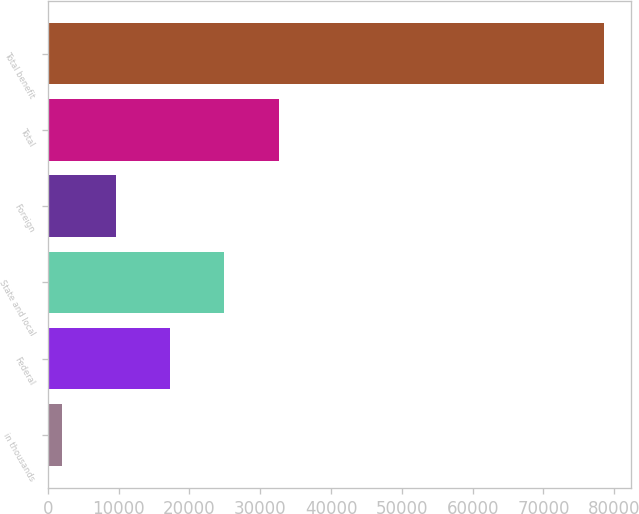Convert chart. <chart><loc_0><loc_0><loc_500><loc_500><bar_chart><fcel>in thousands<fcel>Federal<fcel>State and local<fcel>Foreign<fcel>Total<fcel>Total benefit<nl><fcel>2011<fcel>17305.4<fcel>24952.6<fcel>9658.2<fcel>32599.8<fcel>78483<nl></chart> 